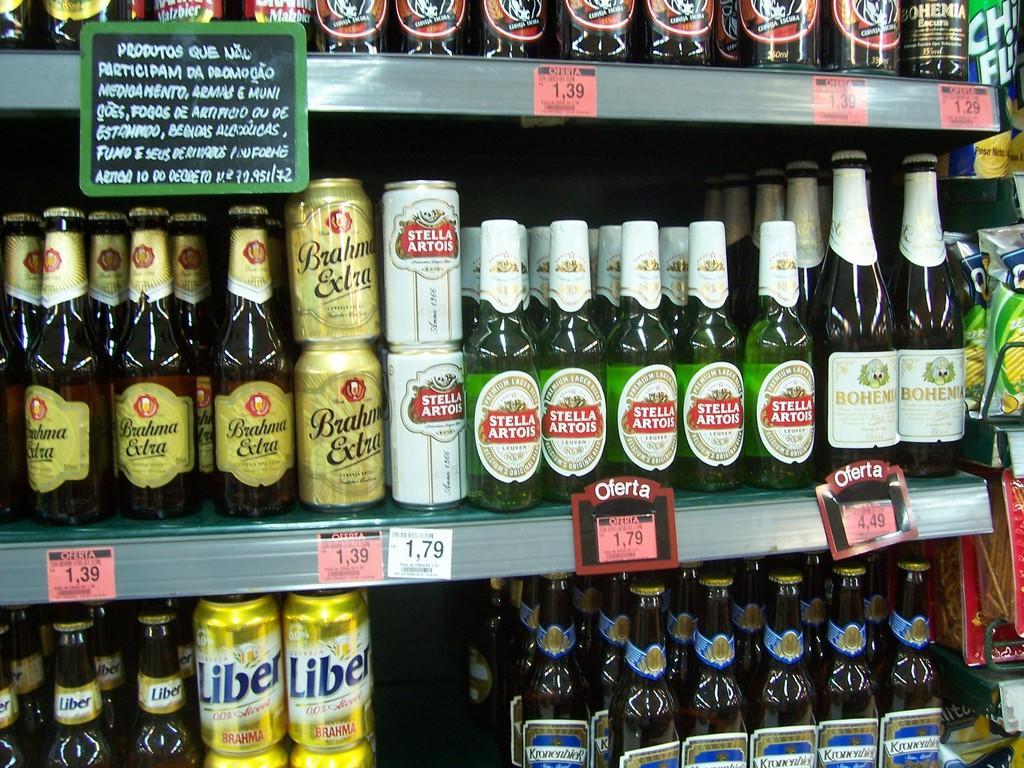Could you give a brief overview of what you see in this image? Here we can see wine bottles in three racks. On the right there are chips packets in three racks. 